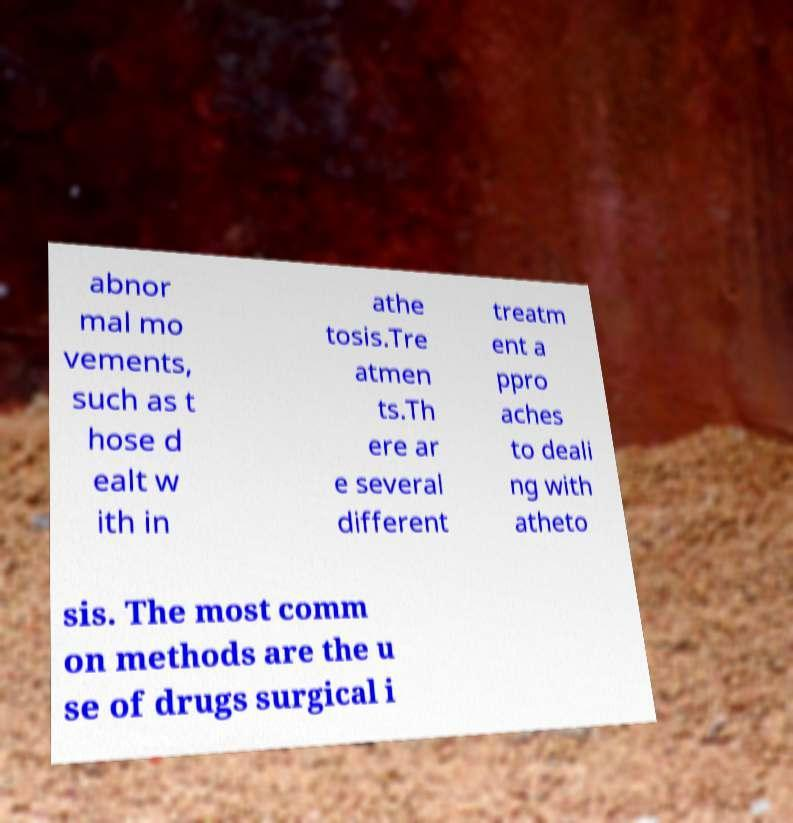Could you extract and type out the text from this image? abnor mal mo vements, such as t hose d ealt w ith in athe tosis.Tre atmen ts.Th ere ar e several different treatm ent a ppro aches to deali ng with atheto sis. The most comm on methods are the u se of drugs surgical i 